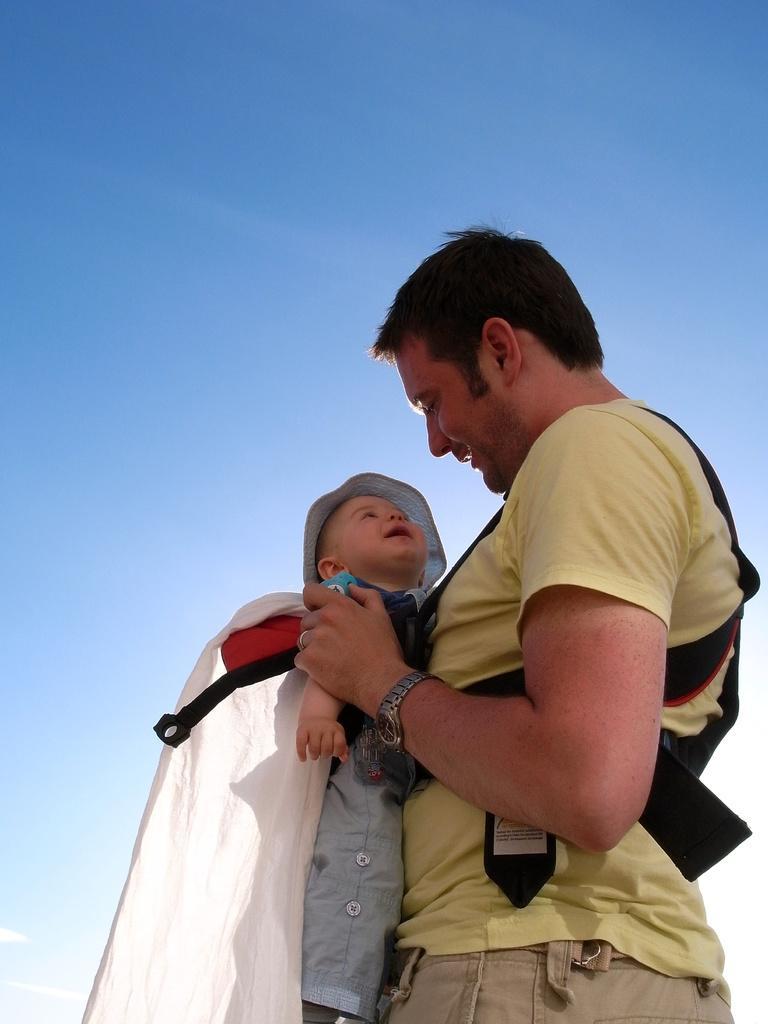Could you give a brief overview of what you see in this image? In this image there is a man holding a kid in his hands, in the background there is there is the sky. 